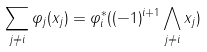<formula> <loc_0><loc_0><loc_500><loc_500>\sum _ { j \neq i } \varphi _ { j } ( x _ { j } ) = \varphi _ { i } ^ { * } ( ( - 1 ) ^ { i + 1 } \bigwedge _ { j \neq i } x _ { j } )</formula> 